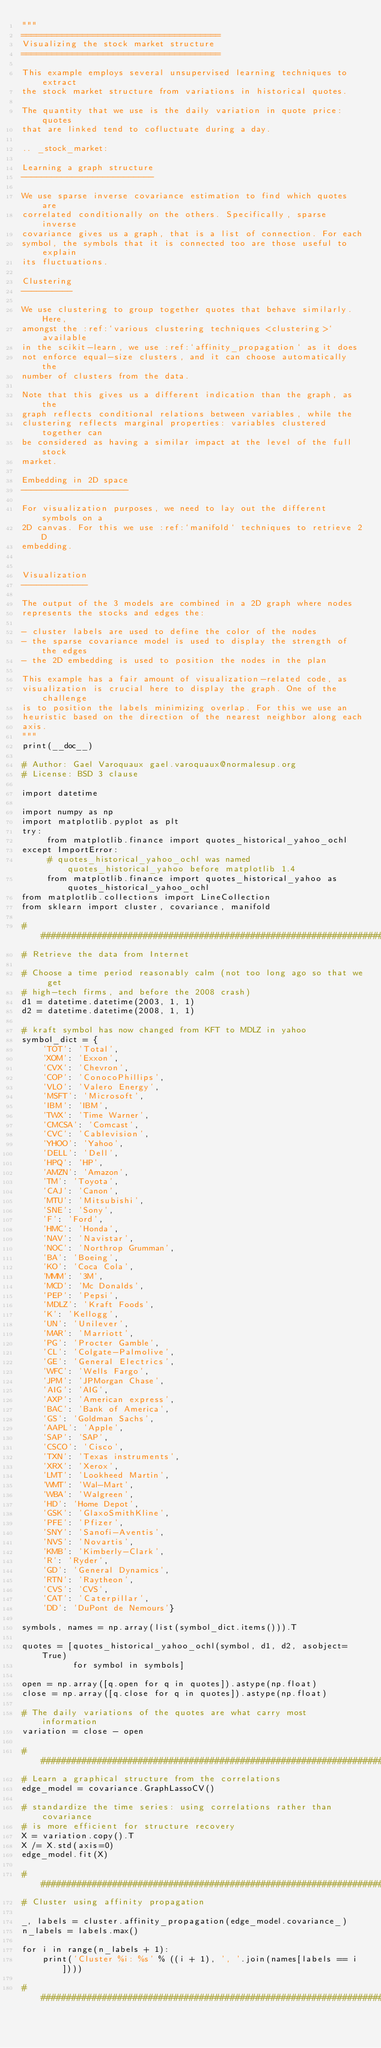<code> <loc_0><loc_0><loc_500><loc_500><_Python_>"""
=======================================
Visualizing the stock market structure
=======================================

This example employs several unsupervised learning techniques to extract
the stock market structure from variations in historical quotes.

The quantity that we use is the daily variation in quote price: quotes
that are linked tend to cofluctuate during a day.

.. _stock_market:

Learning a graph structure
--------------------------

We use sparse inverse covariance estimation to find which quotes are
correlated conditionally on the others. Specifically, sparse inverse
covariance gives us a graph, that is a list of connection. For each
symbol, the symbols that it is connected too are those useful to explain
its fluctuations.

Clustering
----------

We use clustering to group together quotes that behave similarly. Here,
amongst the :ref:`various clustering techniques <clustering>` available
in the scikit-learn, we use :ref:`affinity_propagation` as it does
not enforce equal-size clusters, and it can choose automatically the
number of clusters from the data.

Note that this gives us a different indication than the graph, as the
graph reflects conditional relations between variables, while the
clustering reflects marginal properties: variables clustered together can
be considered as having a similar impact at the level of the full stock
market.

Embedding in 2D space
---------------------

For visualization purposes, we need to lay out the different symbols on a
2D canvas. For this we use :ref:`manifold` techniques to retrieve 2D
embedding.


Visualization
-------------

The output of the 3 models are combined in a 2D graph where nodes
represents the stocks and edges the:

- cluster labels are used to define the color of the nodes
- the sparse covariance model is used to display the strength of the edges
- the 2D embedding is used to position the nodes in the plan

This example has a fair amount of visualization-related code, as
visualization is crucial here to display the graph. One of the challenge
is to position the labels minimizing overlap. For this we use an
heuristic based on the direction of the nearest neighbor along each
axis.
"""
print(__doc__)

# Author: Gael Varoquaux gael.varoquaux@normalesup.org
# License: BSD 3 clause

import datetime

import numpy as np
import matplotlib.pyplot as plt
try:
     from matplotlib.finance import quotes_historical_yahoo_ochl
except ImportError:
     # quotes_historical_yahoo_ochl was named quotes_historical_yahoo before matplotlib 1.4
     from matplotlib.finance import quotes_historical_yahoo as quotes_historical_yahoo_ochl
from matplotlib.collections import LineCollection
from sklearn import cluster, covariance, manifold

###############################################################################
# Retrieve the data from Internet

# Choose a time period reasonably calm (not too long ago so that we get
# high-tech firms, and before the 2008 crash)
d1 = datetime.datetime(2003, 1, 1)
d2 = datetime.datetime(2008, 1, 1)

# kraft symbol has now changed from KFT to MDLZ in yahoo
symbol_dict = {
    'TOT': 'Total',
    'XOM': 'Exxon',
    'CVX': 'Chevron',
    'COP': 'ConocoPhillips',
    'VLO': 'Valero Energy',
    'MSFT': 'Microsoft',
    'IBM': 'IBM',
    'TWX': 'Time Warner',
    'CMCSA': 'Comcast',
    'CVC': 'Cablevision',
    'YHOO': 'Yahoo',
    'DELL': 'Dell',
    'HPQ': 'HP',
    'AMZN': 'Amazon',
    'TM': 'Toyota',
    'CAJ': 'Canon',
    'MTU': 'Mitsubishi',
    'SNE': 'Sony',
    'F': 'Ford',
    'HMC': 'Honda',
    'NAV': 'Navistar',
    'NOC': 'Northrop Grumman',
    'BA': 'Boeing',
    'KO': 'Coca Cola',
    'MMM': '3M',
    'MCD': 'Mc Donalds',
    'PEP': 'Pepsi',
    'MDLZ': 'Kraft Foods',
    'K': 'Kellogg',
    'UN': 'Unilever',
    'MAR': 'Marriott',
    'PG': 'Procter Gamble',
    'CL': 'Colgate-Palmolive',
    'GE': 'General Electrics',
    'WFC': 'Wells Fargo',
    'JPM': 'JPMorgan Chase',
    'AIG': 'AIG',
    'AXP': 'American express',
    'BAC': 'Bank of America',
    'GS': 'Goldman Sachs',
    'AAPL': 'Apple',
    'SAP': 'SAP',
    'CSCO': 'Cisco',
    'TXN': 'Texas instruments',
    'XRX': 'Xerox',
    'LMT': 'Lookheed Martin',
    'WMT': 'Wal-Mart',
    'WBA': 'Walgreen',
    'HD': 'Home Depot',
    'GSK': 'GlaxoSmithKline',
    'PFE': 'Pfizer',
    'SNY': 'Sanofi-Aventis',
    'NVS': 'Novartis',
    'KMB': 'Kimberly-Clark',
    'R': 'Ryder',
    'GD': 'General Dynamics',
    'RTN': 'Raytheon',
    'CVS': 'CVS',
    'CAT': 'Caterpillar',
    'DD': 'DuPont de Nemours'}

symbols, names = np.array(list(symbol_dict.items())).T

quotes = [quotes_historical_yahoo_ochl(symbol, d1, d2, asobject=True)
          for symbol in symbols]

open = np.array([q.open for q in quotes]).astype(np.float)
close = np.array([q.close for q in quotes]).astype(np.float)

# The daily variations of the quotes are what carry most information
variation = close - open

###############################################################################
# Learn a graphical structure from the correlations
edge_model = covariance.GraphLassoCV()

# standardize the time series: using correlations rather than covariance
# is more efficient for structure recovery
X = variation.copy().T
X /= X.std(axis=0)
edge_model.fit(X)

###############################################################################
# Cluster using affinity propagation

_, labels = cluster.affinity_propagation(edge_model.covariance_)
n_labels = labels.max()

for i in range(n_labels + 1):
    print('Cluster %i: %s' % ((i + 1), ', '.join(names[labels == i])))

###############################################################################</code> 